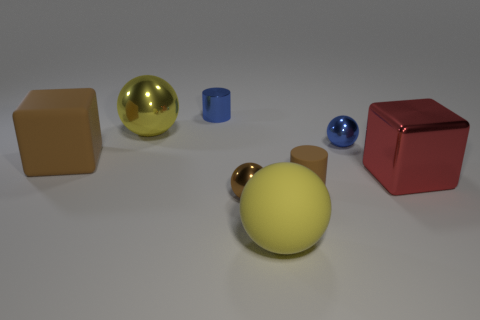Subtract 1 spheres. How many spheres are left? 3 Add 1 tiny rubber cylinders. How many objects exist? 9 Subtract all cylinders. How many objects are left? 6 Add 6 red objects. How many red objects exist? 7 Subtract 0 cyan cylinders. How many objects are left? 8 Subtract all green metal spheres. Subtract all big matte objects. How many objects are left? 6 Add 8 brown rubber cubes. How many brown rubber cubes are left? 9 